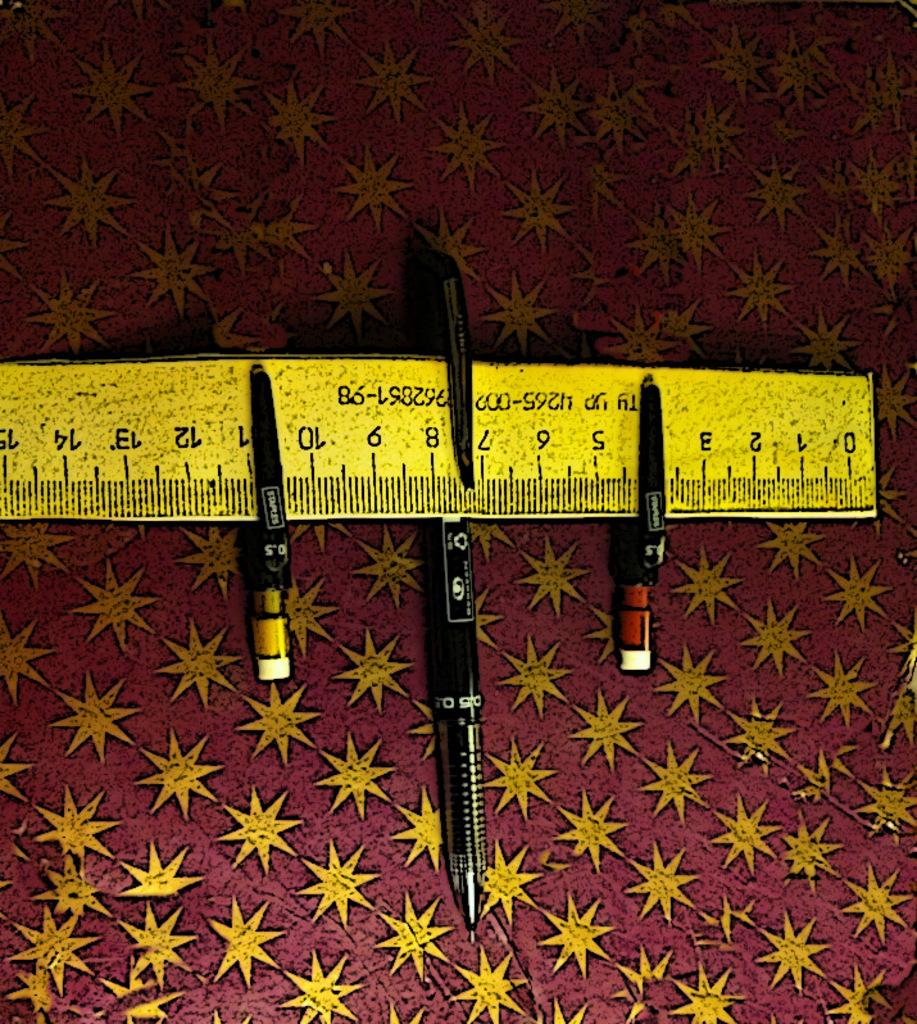<image>
Create a compact narrative representing the image presented. A measuring tape has a pen covering the number 4. 